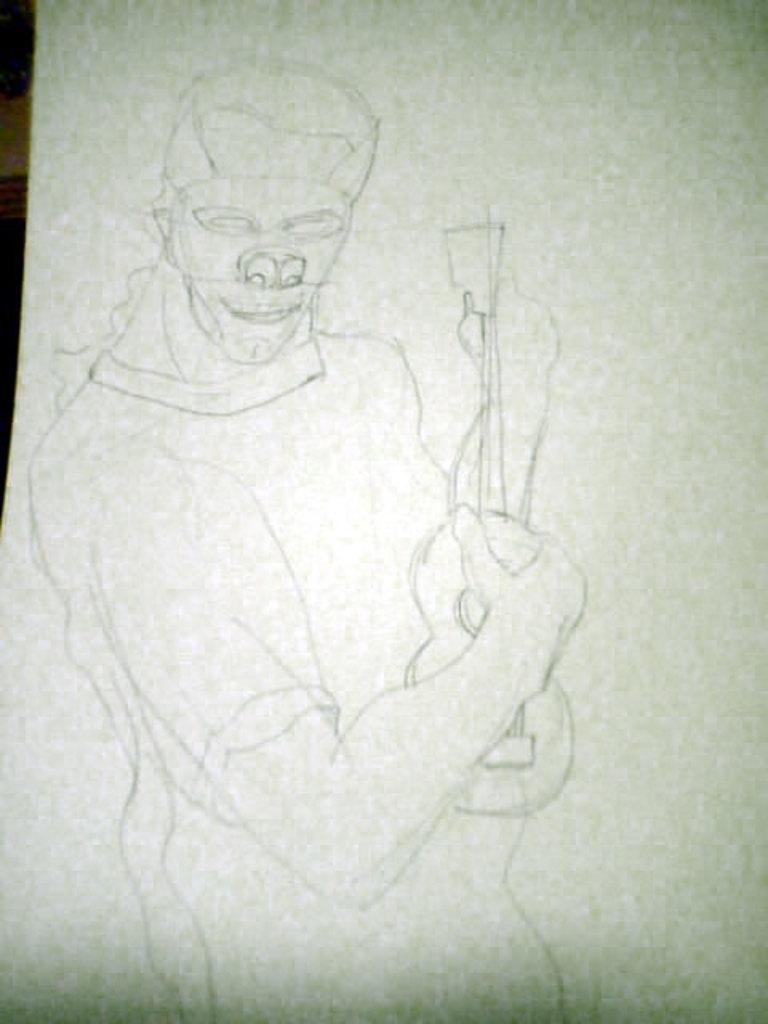What is depicted on the white surface in the image? There is a drawing of a person on a white surface. What is the person in the drawing holding? The person in the drawing is holding a guitar. What type of system is the person in the drawing a part of? There is no system mentioned in the image. 